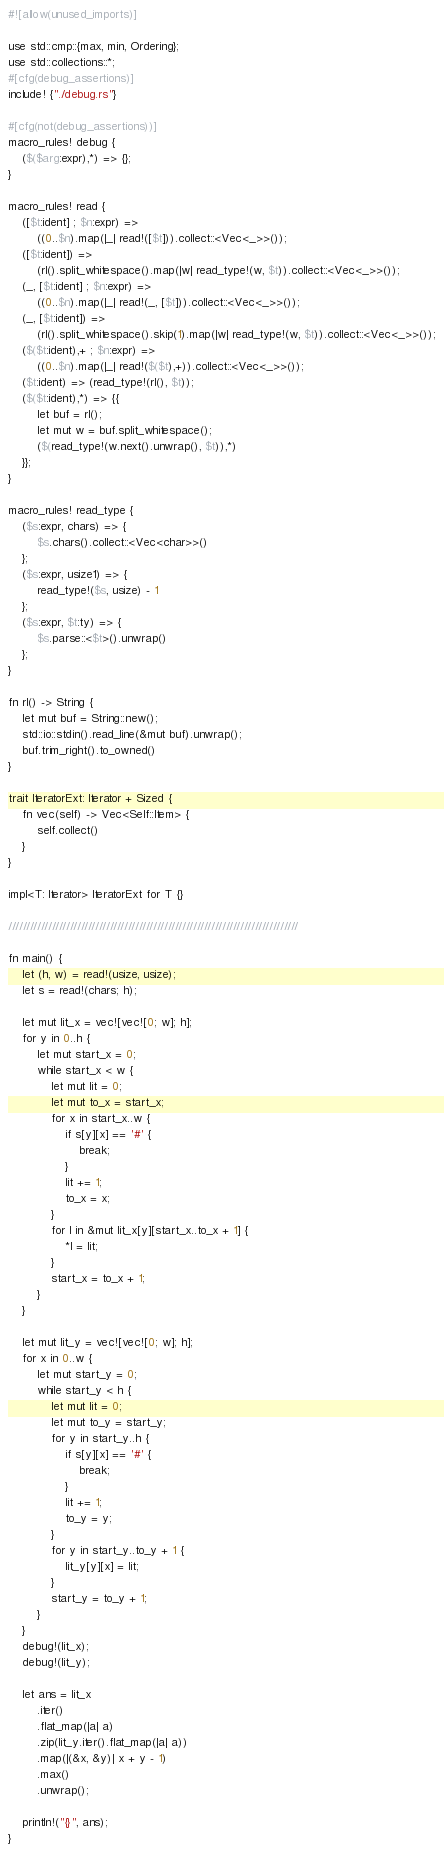Convert code to text. <code><loc_0><loc_0><loc_500><loc_500><_Rust_>#![allow(unused_imports)]

use std::cmp::{max, min, Ordering};
use std::collections::*;
#[cfg(debug_assertions)]
include! {"./debug.rs"}

#[cfg(not(debug_assertions))]
macro_rules! debug {
    ($($arg:expr),*) => {};
}

macro_rules! read {
    ([$t:ident] ; $n:expr) =>
        ((0..$n).map(|_| read!([$t])).collect::<Vec<_>>());
    ([$t:ident]) =>
        (rl().split_whitespace().map(|w| read_type!(w, $t)).collect::<Vec<_>>());
    (_, [$t:ident] ; $n:expr) =>
        ((0..$n).map(|_| read!(_, [$t])).collect::<Vec<_>>());
    (_, [$t:ident]) =>
        (rl().split_whitespace().skip(1).map(|w| read_type!(w, $t)).collect::<Vec<_>>());
    ($($t:ident),+ ; $n:expr) =>
        ((0..$n).map(|_| read!($($t),+)).collect::<Vec<_>>());
    ($t:ident) => (read_type!(rl(), $t));
    ($($t:ident),*) => {{
        let buf = rl();
        let mut w = buf.split_whitespace();
        ($(read_type!(w.next().unwrap(), $t)),*)
    }};
}

macro_rules! read_type {
    ($s:expr, chars) => {
        $s.chars().collect::<Vec<char>>()
    };
    ($s:expr, usize1) => {
        read_type!($s, usize) - 1
    };
    ($s:expr, $t:ty) => {
        $s.parse::<$t>().unwrap()
    };
}

fn rl() -> String {
    let mut buf = String::new();
    std::io::stdin().read_line(&mut buf).unwrap();
    buf.trim_right().to_owned()
}

trait IteratorExt: Iterator + Sized {
    fn vec(self) -> Vec<Self::Item> {
        self.collect()
    }
}

impl<T: Iterator> IteratorExt for T {}

////////////////////////////////////////////////////////////////////////////////

fn main() {
    let (h, w) = read!(usize, usize);
    let s = read!(chars; h);

    let mut lit_x = vec![vec![0; w]; h];
    for y in 0..h {
        let mut start_x = 0;
        while start_x < w {
            let mut lit = 0;
            let mut to_x = start_x;
            for x in start_x..w {
                if s[y][x] == '#' {
                    break;
                }
                lit += 1;
                to_x = x;
            }
            for l in &mut lit_x[y][start_x..to_x + 1] {
                *l = lit;
            }
            start_x = to_x + 1;
        }
    }

    let mut lit_y = vec![vec![0; w]; h];
    for x in 0..w {
        let mut start_y = 0;
        while start_y < h {
            let mut lit = 0;
            let mut to_y = start_y;
            for y in start_y..h {
                if s[y][x] == '#' {
                    break;
                }
                lit += 1;
                to_y = y;
            }
            for y in start_y..to_y + 1 {
                lit_y[y][x] = lit;
            }
            start_y = to_y + 1;
        }
    }
    debug!(lit_x);
    debug!(lit_y);

    let ans = lit_x
        .iter()
        .flat_map(|a| a)
        .zip(lit_y.iter().flat_map(|a| a))
        .map(|(&x, &y)| x + y - 1)
        .max()
        .unwrap();

    println!("{}", ans);
}
</code> 